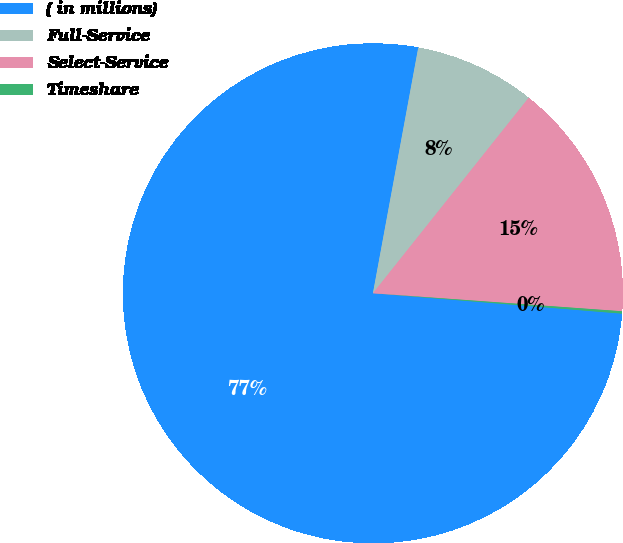<chart> <loc_0><loc_0><loc_500><loc_500><pie_chart><fcel>( in millions)<fcel>Full-Service<fcel>Select-Service<fcel>Timeshare<nl><fcel>76.61%<fcel>7.8%<fcel>15.44%<fcel>0.15%<nl></chart> 